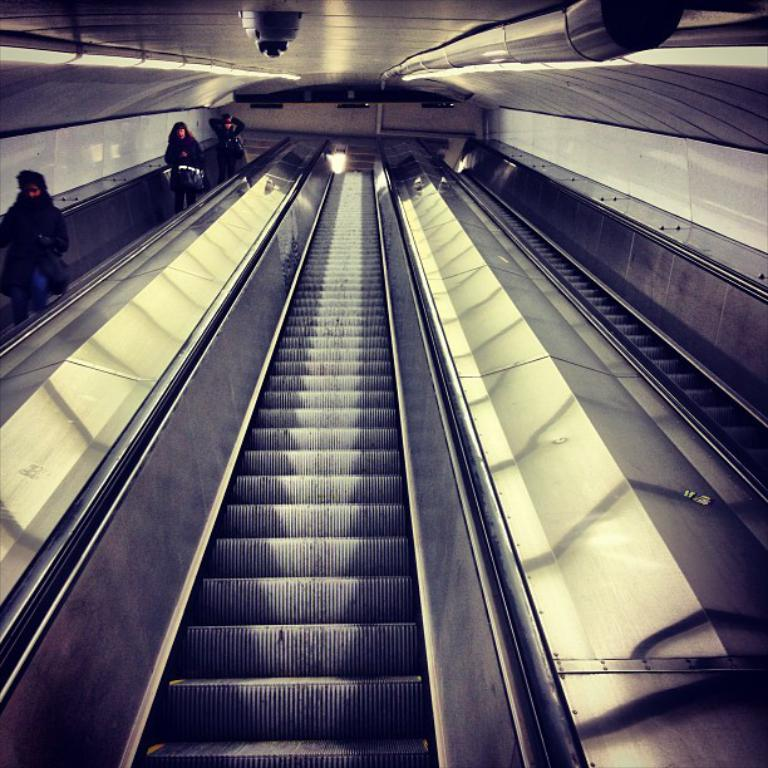Who or what is present in the image? There are people in the image. What are the people doing in the image? The people are on an escalator. What else can be seen in the image besides the people? There are lights visible in the image. What type of crate is being used to transport the attraction in the image? There is no crate or attraction present in the image; it features people on an escalator and lights. 